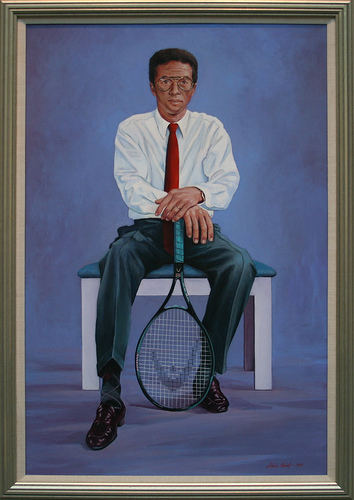Please provide a short description for this region: [0.46, 0.37, 0.57, 0.5]. Hands resting on a tennis racket handle. 